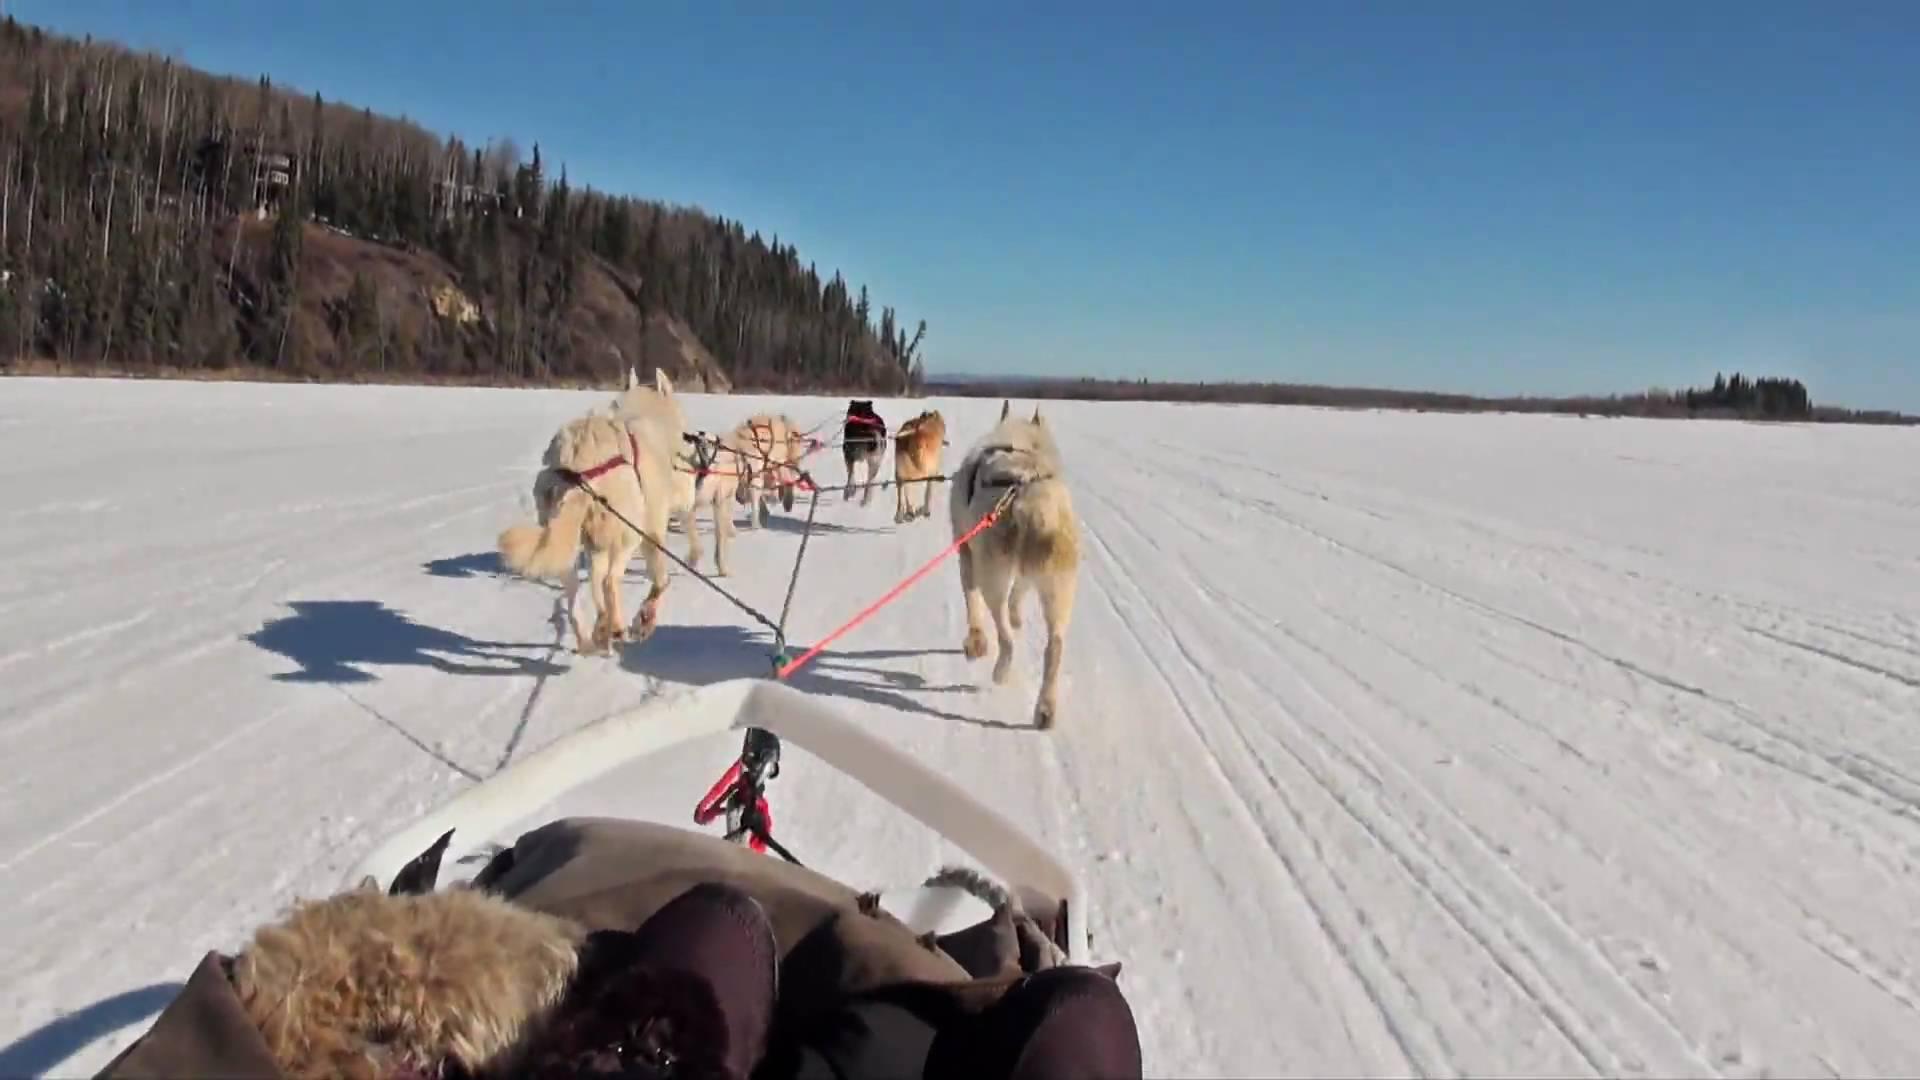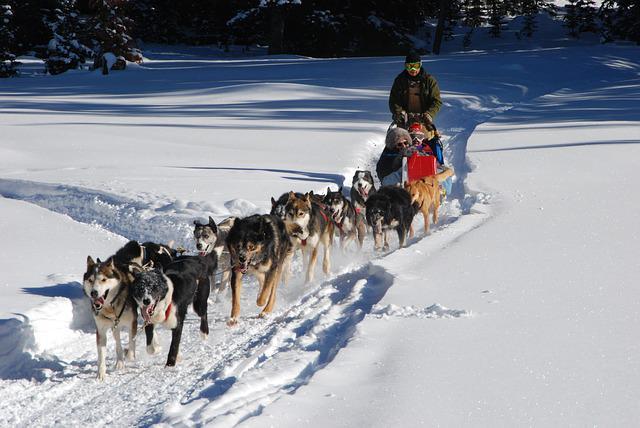The first image is the image on the left, the second image is the image on the right. Given the left and right images, does the statement "All of the humans in the right photo are wearing red jackets." hold true? Answer yes or no. No. 